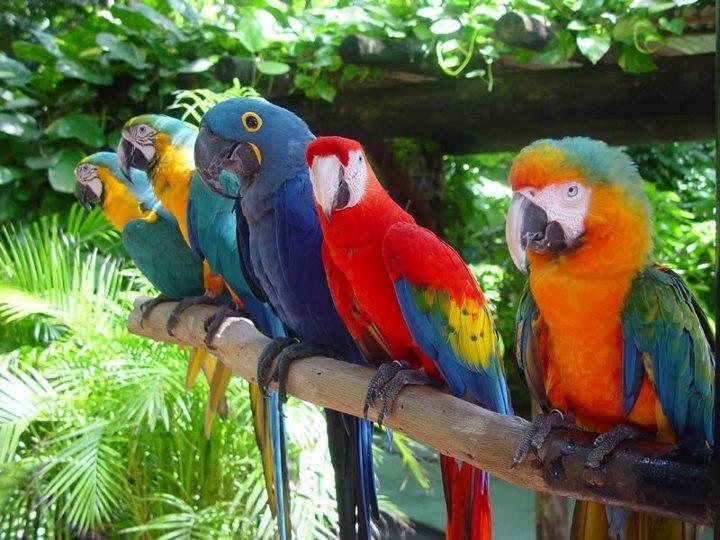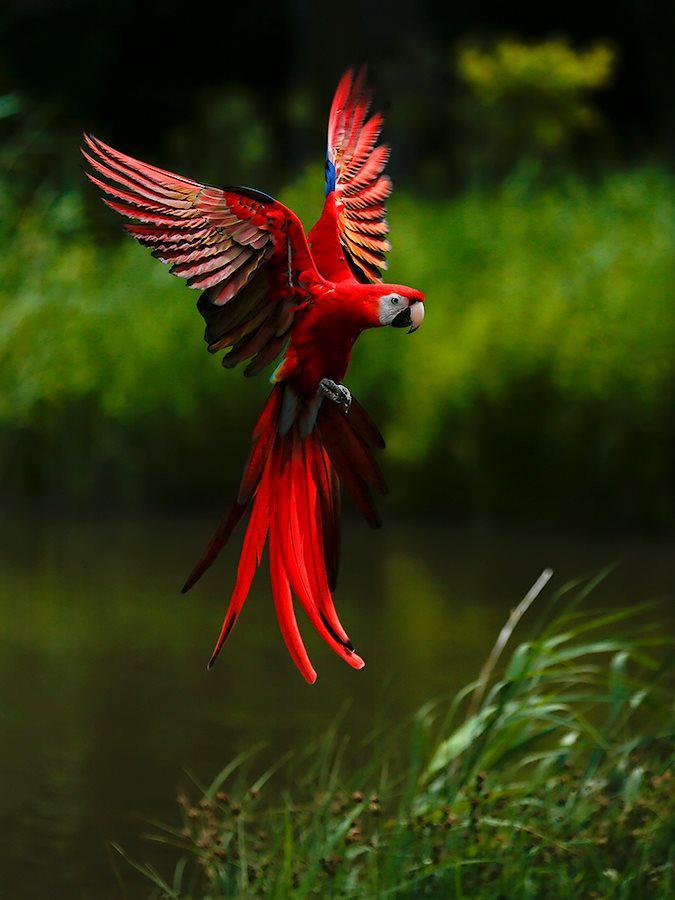The first image is the image on the left, the second image is the image on the right. Given the left and right images, does the statement "An image shows a single parrot in flight." hold true? Answer yes or no. Yes. 